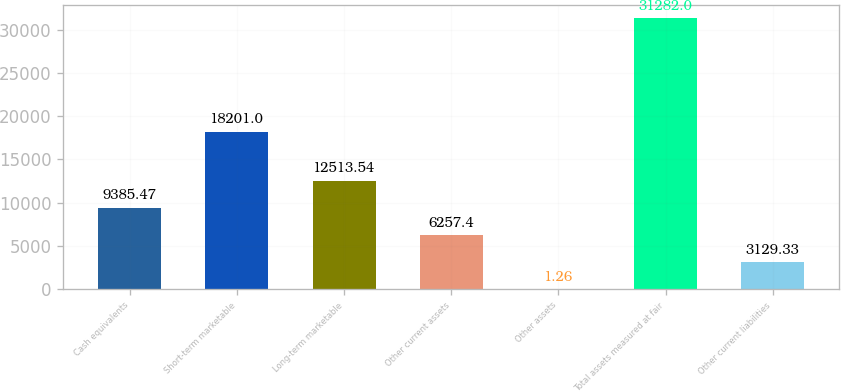Convert chart to OTSL. <chart><loc_0><loc_0><loc_500><loc_500><bar_chart><fcel>Cash equivalents<fcel>Short-term marketable<fcel>Long-term marketable<fcel>Other current assets<fcel>Other assets<fcel>Total assets measured at fair<fcel>Other current liabilities<nl><fcel>9385.47<fcel>18201<fcel>12513.5<fcel>6257.4<fcel>1.26<fcel>31282<fcel>3129.33<nl></chart> 